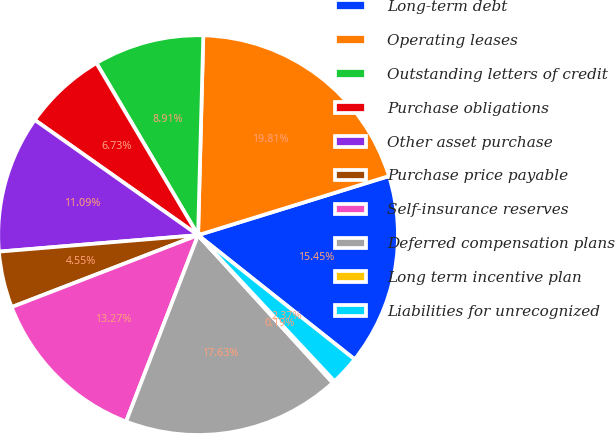Convert chart to OTSL. <chart><loc_0><loc_0><loc_500><loc_500><pie_chart><fcel>Long-term debt<fcel>Operating leases<fcel>Outstanding letters of credit<fcel>Purchase obligations<fcel>Other asset purchase<fcel>Purchase price payable<fcel>Self-insurance reserves<fcel>Deferred compensation plans<fcel>Long term incentive plan<fcel>Liabilities for unrecognized<nl><fcel>15.45%<fcel>19.81%<fcel>8.91%<fcel>6.73%<fcel>11.09%<fcel>4.55%<fcel>13.27%<fcel>17.63%<fcel>0.19%<fcel>2.37%<nl></chart> 